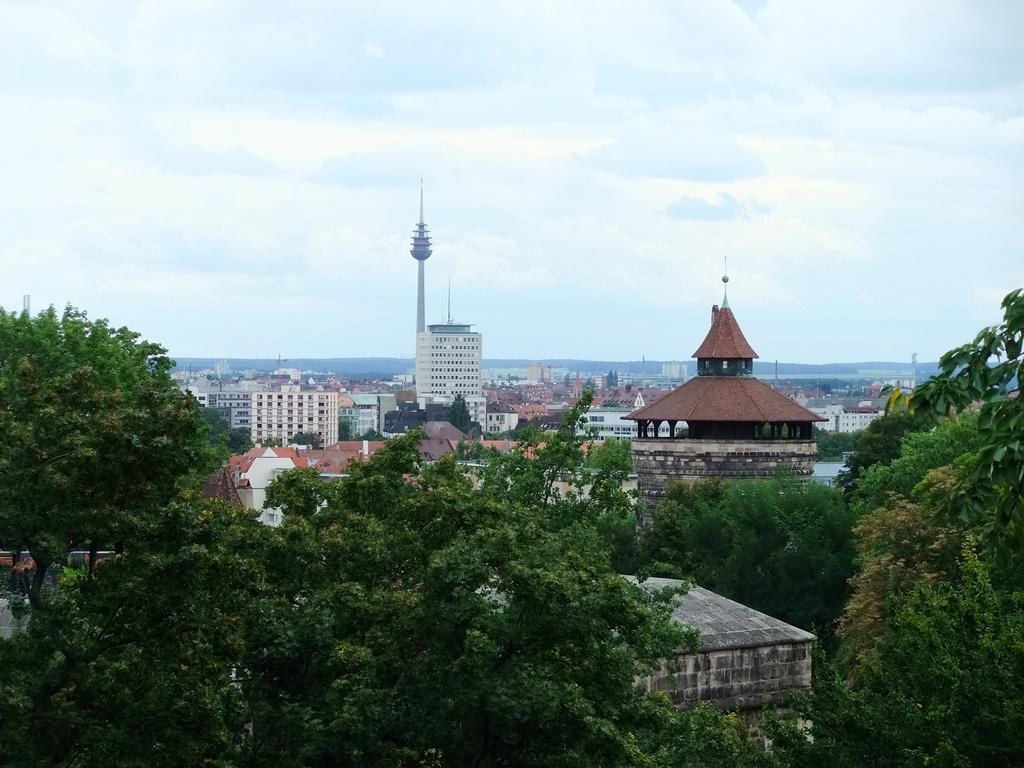What type of natural elements can be seen in the image? There are trees in the image. What type of man-made structures are present in the image? There are buildings and a tower in the image. What type of landscape feature can be seen in the image? There are hills in the image. What is visible in the sky in the image? The sky is visible in the image. How many cars are parked on the stick in the image? There are no cars or sticks present in the image. Can you see a duck swimming in the image? There is no duck present in the image. 